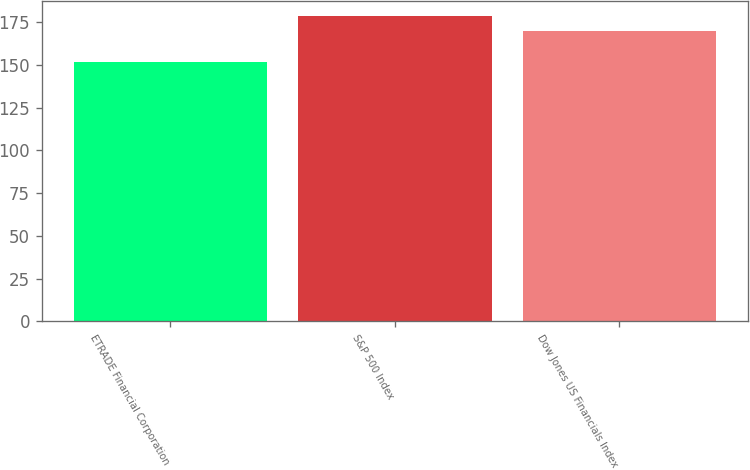<chart> <loc_0><loc_0><loc_500><loc_500><bar_chart><fcel>ETRADE Financial Corporation<fcel>S&P 500 Index<fcel>Dow Jones US Financials Index<nl><fcel>151.59<fcel>178.29<fcel>170.04<nl></chart> 